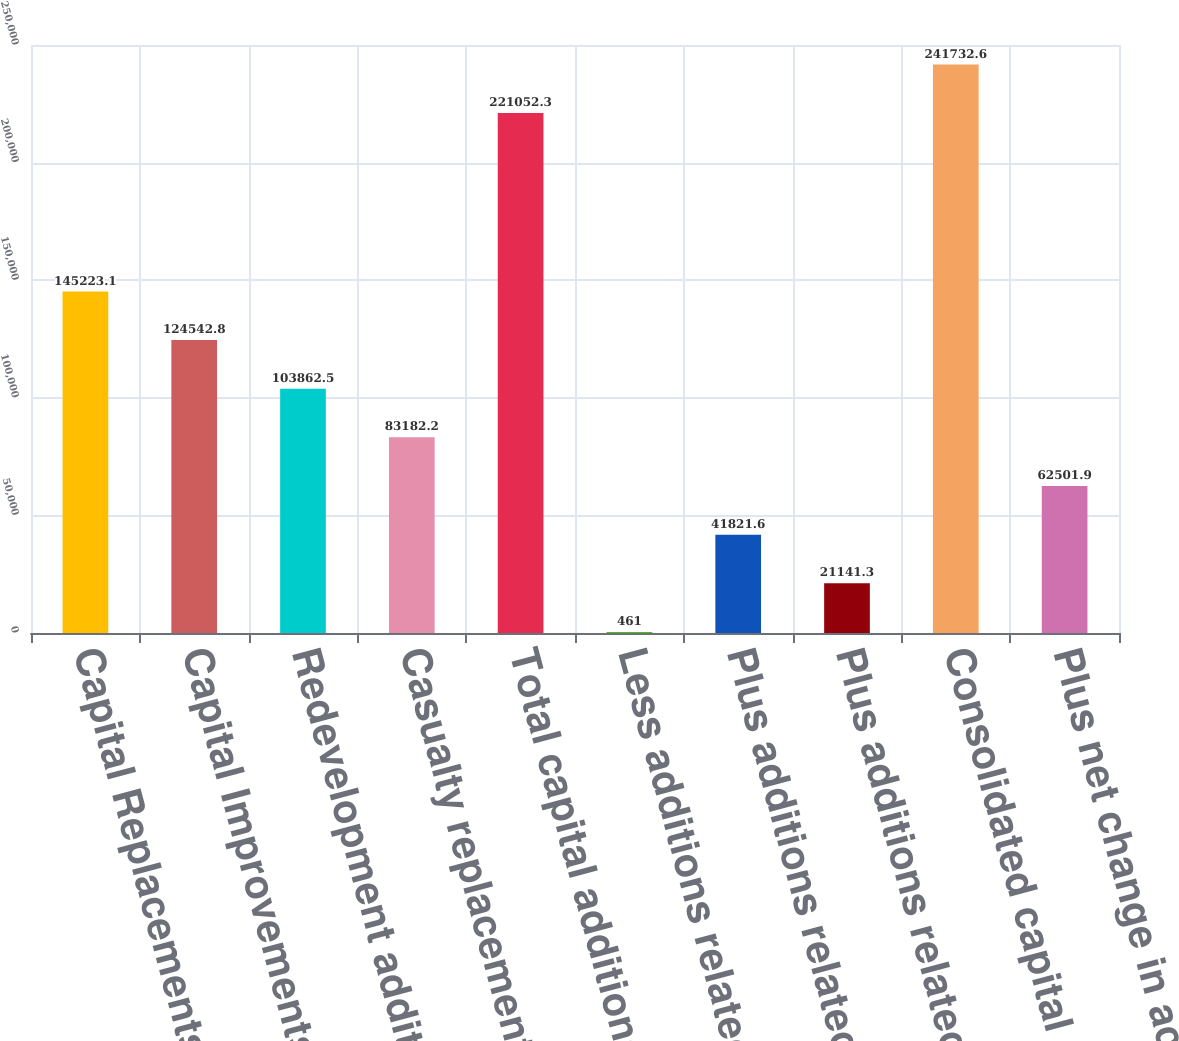Convert chart. <chart><loc_0><loc_0><loc_500><loc_500><bar_chart><fcel>Capital Replacements<fcel>Capital Improvements<fcel>Redevelopment additions<fcel>Casualty replacements<fcel>Total capital additions<fcel>Less additions related to<fcel>Plus additions related to sold<fcel>Plus additions related to<fcel>Consolidated capital additions<fcel>Plus net change in accrued<nl><fcel>145223<fcel>124543<fcel>103862<fcel>83182.2<fcel>221052<fcel>461<fcel>41821.6<fcel>21141.3<fcel>241733<fcel>62501.9<nl></chart> 